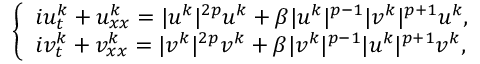<formula> <loc_0><loc_0><loc_500><loc_500>\begin{array} { r } { \left \{ \begin{array} { l } { i u _ { t } ^ { k } + u _ { x x } ^ { k } = | u ^ { k } | ^ { 2 p } u ^ { k } + \beta | u ^ { k } | ^ { p - 1 } | v ^ { k } | ^ { p + 1 } u ^ { k } , } \\ { i v _ { t } ^ { k } + v _ { x x } ^ { k } = | v ^ { k } | ^ { 2 p } v ^ { k } + \beta | v ^ { k } | ^ { p - 1 } | u ^ { k } | ^ { p + 1 } v ^ { k } , } \end{array} } \end{array}</formula> 